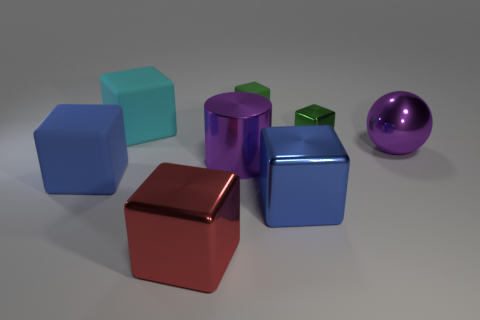The green block that is the same material as the red cube is what size?
Offer a very short reply. Small. Is there a big ball on the right side of the blue object that is in front of the large matte block in front of the purple metallic sphere?
Your response must be concise. Yes. There is a block that is in front of the blue metal object; is its size the same as the blue metallic thing?
Keep it short and to the point. Yes. What number of blue shiny objects have the same size as the purple metal cylinder?
Keep it short and to the point. 1. There is a metal object that is the same color as the small matte object; what is its size?
Make the answer very short. Small. Is the shiny cylinder the same color as the metallic sphere?
Ensure brevity in your answer.  Yes. What is the shape of the tiny green metal thing?
Provide a succinct answer. Cube. Are there any big metallic spheres that have the same color as the big cylinder?
Provide a succinct answer. Yes. Is the number of big rubber cubes in front of the green metallic object greater than the number of large yellow cylinders?
Your answer should be compact. Yes. There is a tiny green matte object; is its shape the same as the big rubber object in front of the large metal cylinder?
Provide a short and direct response. Yes. 